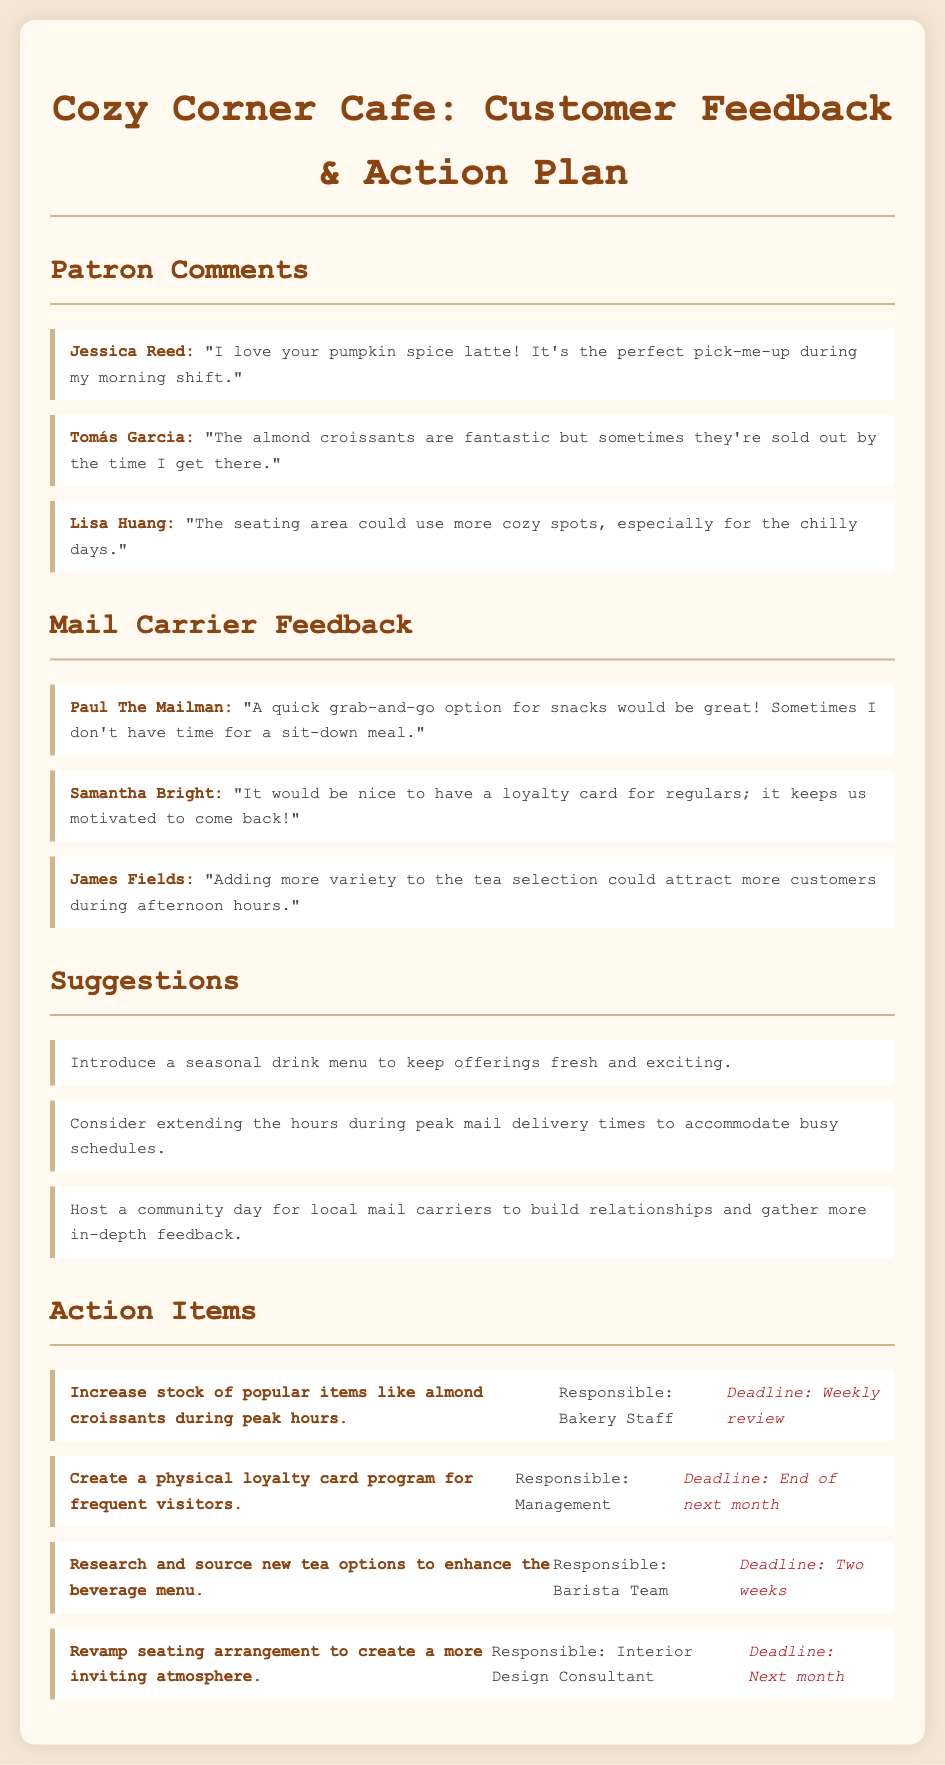What is the name of the cafe? The name of the cafe is stated at the top of the document.
Answer: Cozy Corner Cafe Who provided feedback about the almond croissants? The patron who commented on the almond croissants is mentioned in the document.
Answer: Tomás Garcia How many suggestions are listed in the document? The document contains a list of suggestions under the specified heading.
Answer: Three What is one action item assigned to the Bakery Staff? The document specifies an action item that relates to popular items for the Bakery Staff.
Answer: Increase stock of popular items like almond croissants during peak hours What is the deadline to create a loyalty card program? The deadline for the loyalty card program is noted in the action items section.
Answer: End of next month What is the purpose of introducing a seasonal drink menu? This suggestion is aimed to enhance the cafe experience by keeping offerings fresh and exciting.
Answer: To keep offerings fresh and exciting Which mail carrier suggested a grab-and-go snack option? The mail carrier who suggested this option is mentioned in the feedback section.
Answer: Paul The Mailman How often should the stock of popular items be reviewed? The action item for reviewing stock indicates how frequently it should be checked.
Answer: Weekly review 